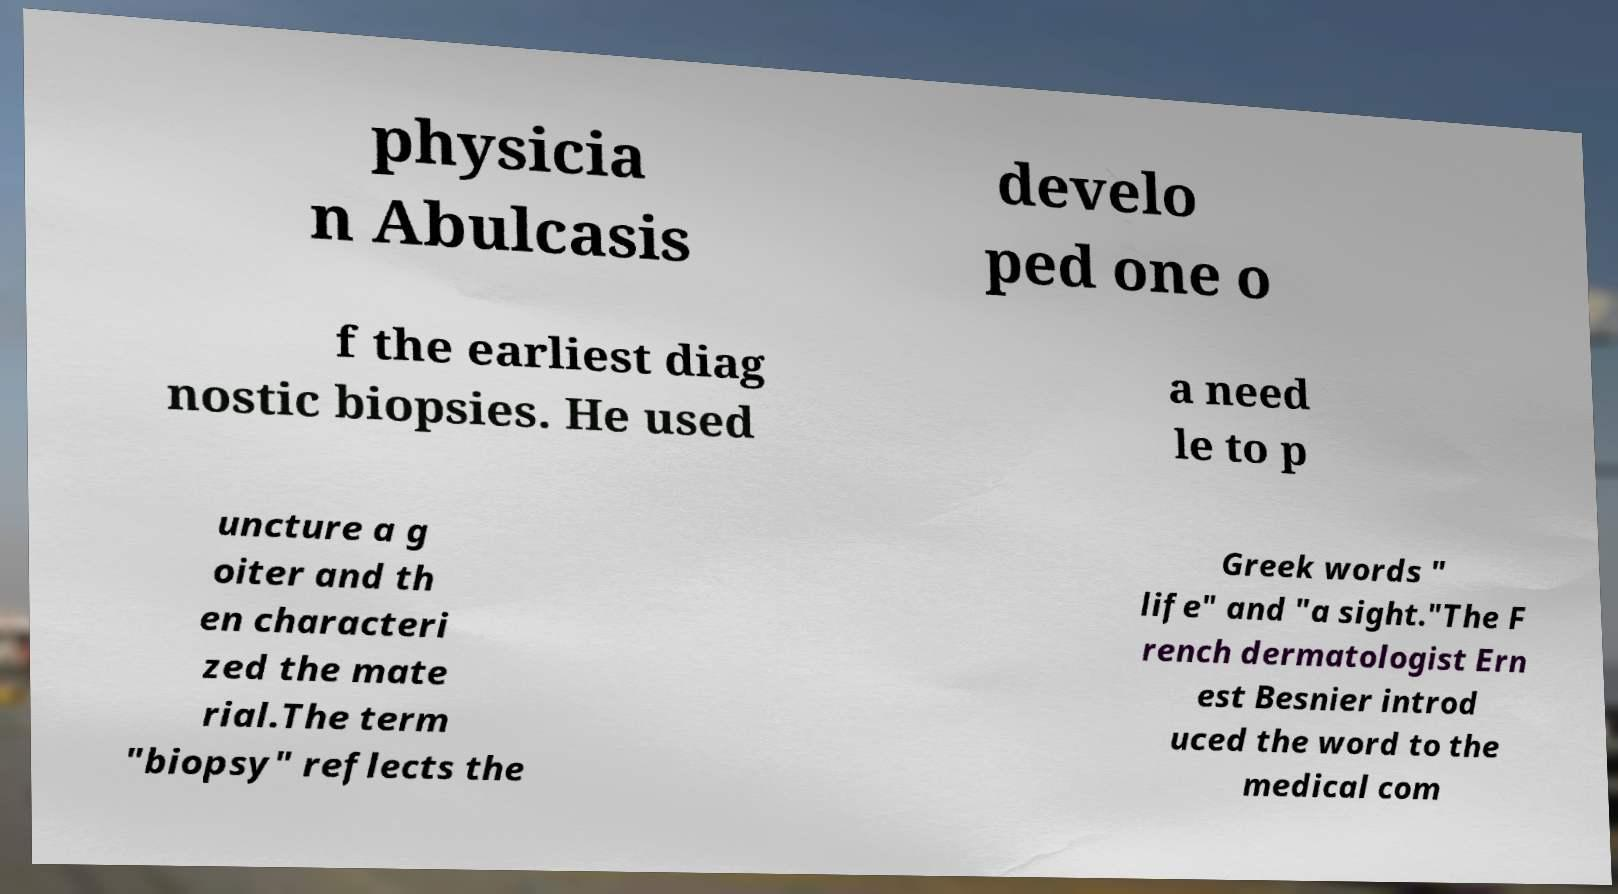Could you extract and type out the text from this image? physicia n Abulcasis develo ped one o f the earliest diag nostic biopsies. He used a need le to p uncture a g oiter and th en characteri zed the mate rial.The term "biopsy" reflects the Greek words " life" and "a sight."The F rench dermatologist Ern est Besnier introd uced the word to the medical com 